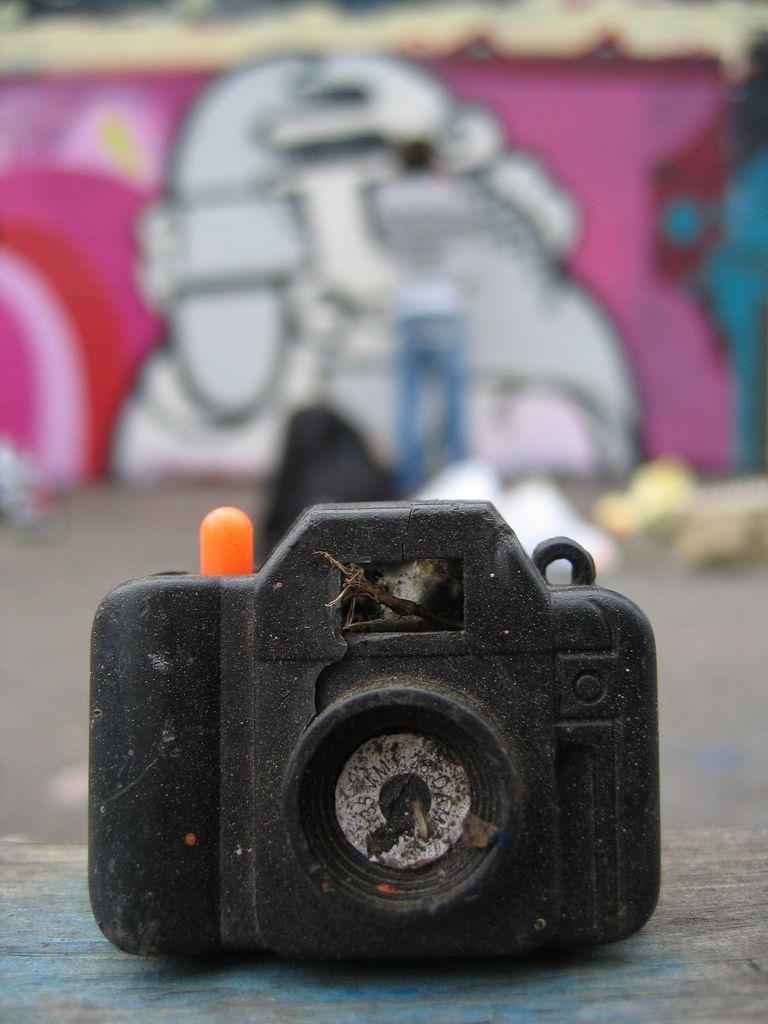Can you describe this image briefly? In this image in the foreground there is a camera, and in the background there is one person, wall and on the wall there is graffiti. At the bottom there is walkway. 